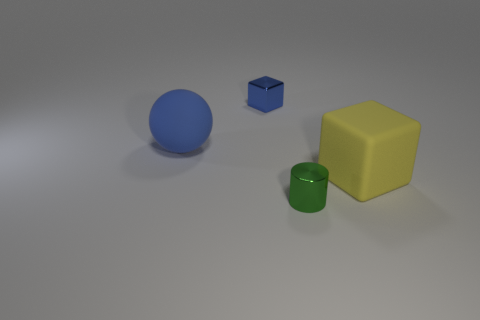Add 1 small green metallic cylinders. How many objects exist? 5 Subtract all balls. How many objects are left? 3 Subtract all blue blocks. Subtract all cylinders. How many objects are left? 2 Add 2 small green metallic things. How many small green metallic things are left? 3 Add 4 blue rubber balls. How many blue rubber balls exist? 5 Subtract 0 brown cubes. How many objects are left? 4 